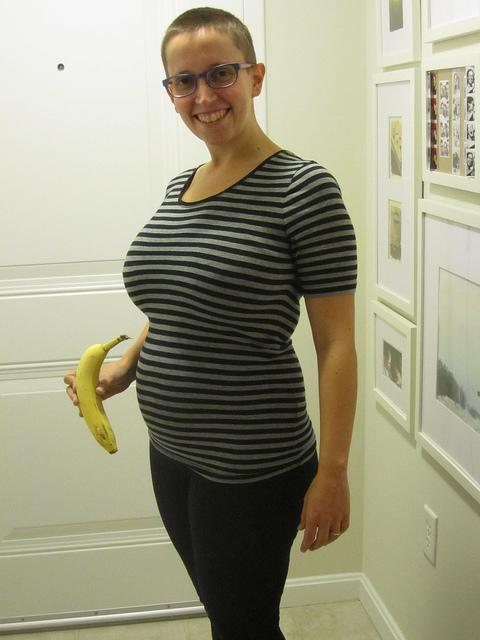What fruit is pictured?
Quick response, please. Banana. Is the woman's hair very short?
Concise answer only. Yes. What is the woman wearing on her eyes?
Quick response, please. Glasses. 